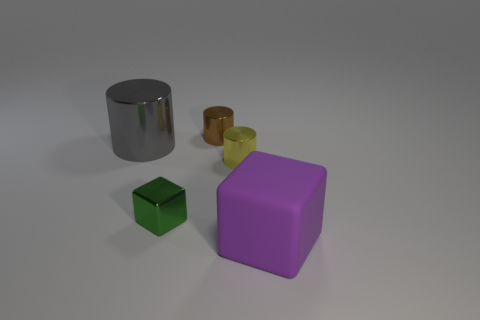Subtract all large cylinders. How many cylinders are left? 2 Subtract all cylinders. How many objects are left? 2 Add 5 tiny yellow metal objects. How many objects exist? 10 Subtract 3 cylinders. How many cylinders are left? 0 Subtract all green cylinders. Subtract all green spheres. How many cylinders are left? 3 Subtract all red cylinders. How many green cubes are left? 1 Subtract all big objects. Subtract all small green cubes. How many objects are left? 2 Add 5 metallic cylinders. How many metallic cylinders are left? 8 Add 2 small blocks. How many small blocks exist? 3 Subtract all purple blocks. How many blocks are left? 1 